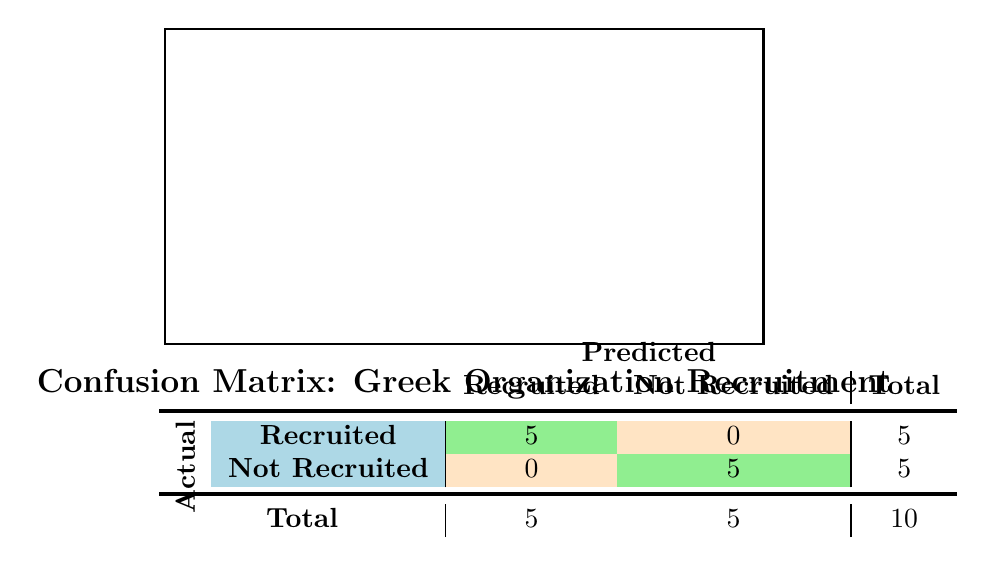What is the total number of participants that were recruited? The table shows that there are 5 participants in the "Recruited" row, aggregating the numbers directly from the table under "Recruited."
Answer: 5 How many participants were not recruited? The table indicates that there are 5 participants in the "Not Recruited" row, as shown by the total combined in that category.
Answer: 5 What fraternity/sorority had the most recruited participants? Since all recruited participants are counted in the "Recruited" category and the sororities do not exceed 5 total, it does not specify a specific fraternity/sorority that had the most recruits within the given dataset in the matrix.
Answer: Cannot be determined Was there a participant who was both recruited and not recruited? The table clearly distinguishes between the "Recruited" and "Not Recruited" categories, thus no participant can be both.
Answer: No If we look only at undergraduate males, how many were recruited? From the data, we see two undergraduate males in the "Recruited" state (Sigma Chi and Phi Delta Theta) contrasting with those categorized as "Not Recruited." Thus they make perfect recruitment successes.
Answer: 2 What is the recruitment success rate for undergraduate females? From the table, there are 3 recruited and 1 not recruited from the undergraduate females (Alpha Delta Pi, Delta Gamma, Chi Omega), which gives us a success rate of 3/(3+1) = 3/4 or 0.75 after calculation.
Answer: 0.75 Are graduate females represented in the recruited category? The table explicitly shows that there are no graduate females in the "Recruited" category.
Answer: No How many total predictions were made? Looking at the "Total" column at the bottom of the table, it states there are a total of 10 predictions made by summing both recruited and not recruited categories.
Answer: 10 Which group had a recruitment success with a status of "Recruited" and is identified as graduate? From the table, there is one graduate male (Sigma Nu) who was recruited, showing diversity in the success status among genders and demographics in recruitment.
Answer: Sigma Nu 